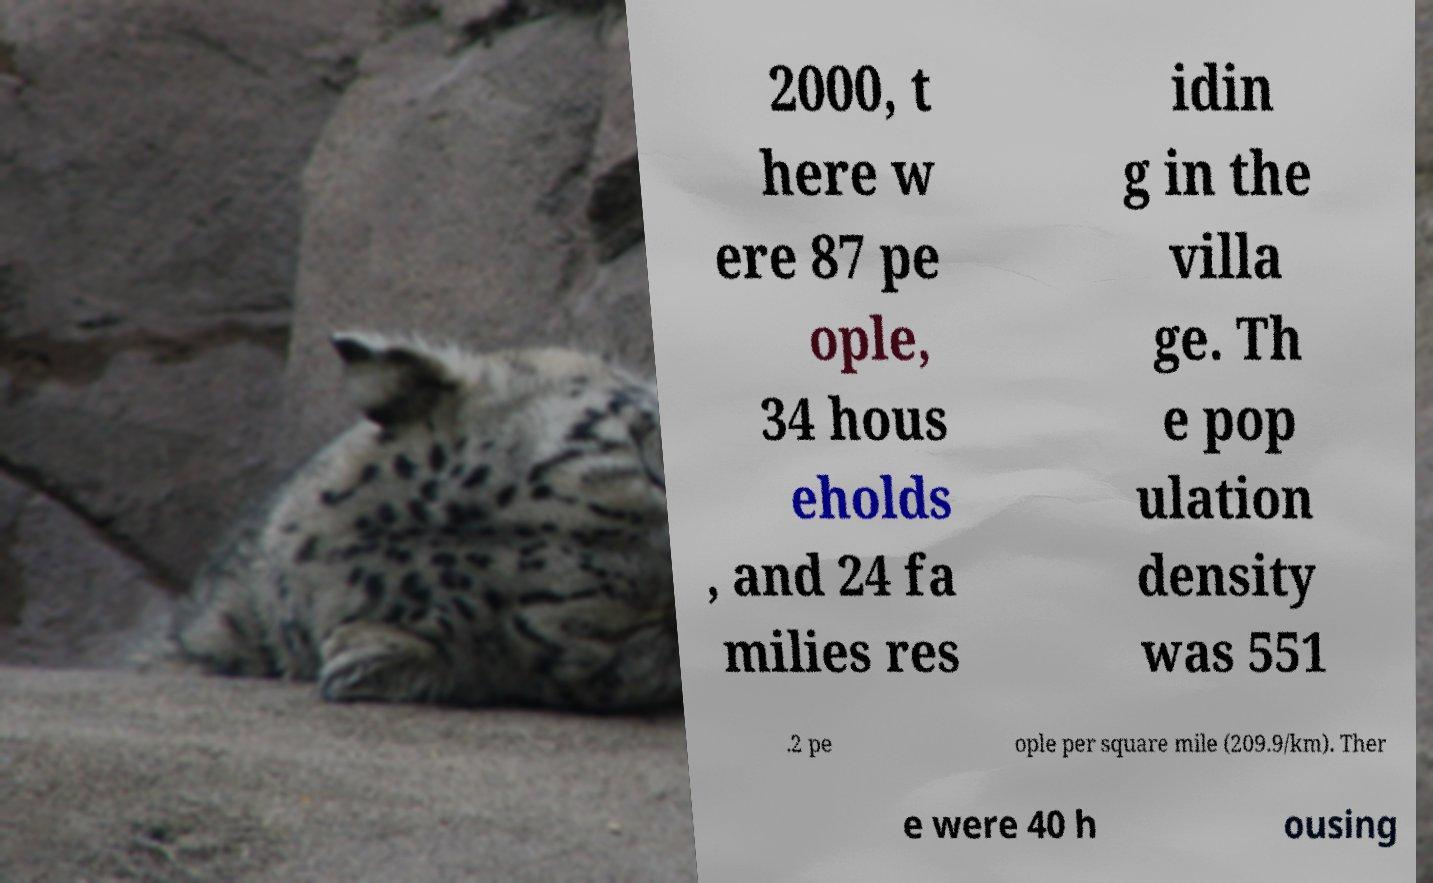Please identify and transcribe the text found in this image. 2000, t here w ere 87 pe ople, 34 hous eholds , and 24 fa milies res idin g in the villa ge. Th e pop ulation density was 551 .2 pe ople per square mile (209.9/km). Ther e were 40 h ousing 